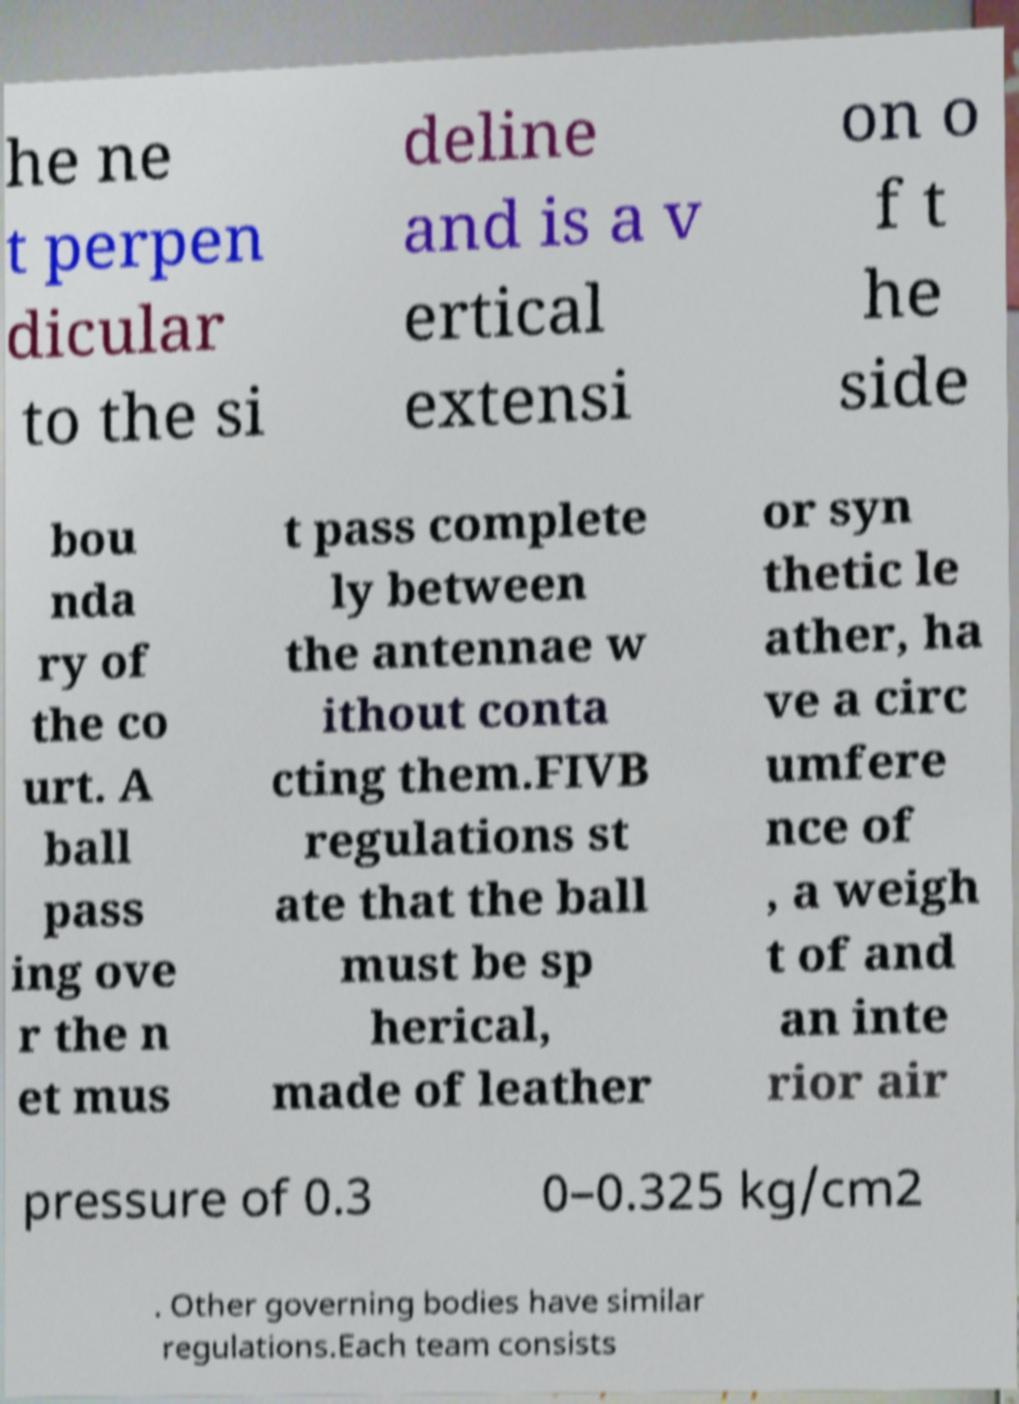What messages or text are displayed in this image? I need them in a readable, typed format. he ne t perpen dicular to the si deline and is a v ertical extensi on o f t he side bou nda ry of the co urt. A ball pass ing ove r the n et mus t pass complete ly between the antennae w ithout conta cting them.FIVB regulations st ate that the ball must be sp herical, made of leather or syn thetic le ather, ha ve a circ umfere nce of , a weigh t of and an inte rior air pressure of 0.3 0–0.325 kg/cm2 . Other governing bodies have similar regulations.Each team consists 